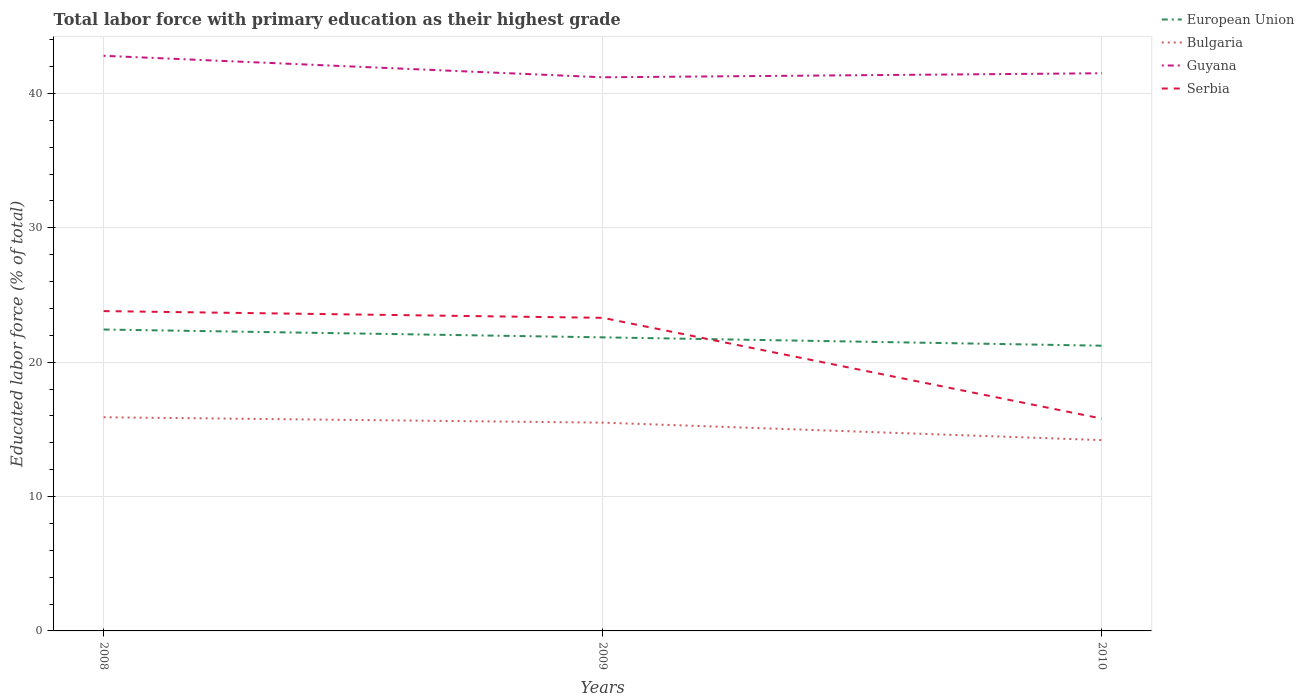Does the line corresponding to Guyana intersect with the line corresponding to European Union?
Your response must be concise. No. Is the number of lines equal to the number of legend labels?
Make the answer very short. Yes. Across all years, what is the maximum percentage of total labor force with primary education in European Union?
Ensure brevity in your answer.  21.22. What is the total percentage of total labor force with primary education in Serbia in the graph?
Ensure brevity in your answer.  7.5. What is the difference between the highest and the second highest percentage of total labor force with primary education in European Union?
Give a very brief answer. 1.2. What is the difference between the highest and the lowest percentage of total labor force with primary education in Serbia?
Your answer should be compact. 2. Is the percentage of total labor force with primary education in Bulgaria strictly greater than the percentage of total labor force with primary education in Serbia over the years?
Give a very brief answer. Yes. How many years are there in the graph?
Provide a succinct answer. 3. What is the difference between two consecutive major ticks on the Y-axis?
Your answer should be compact. 10. Does the graph contain any zero values?
Provide a short and direct response. No. Where does the legend appear in the graph?
Offer a terse response. Top right. How many legend labels are there?
Make the answer very short. 4. How are the legend labels stacked?
Ensure brevity in your answer.  Vertical. What is the title of the graph?
Make the answer very short. Total labor force with primary education as their highest grade. Does "Ukraine" appear as one of the legend labels in the graph?
Your response must be concise. No. What is the label or title of the Y-axis?
Your answer should be compact. Educated labor force (% of total). What is the Educated labor force (% of total) of European Union in 2008?
Offer a very short reply. 22.43. What is the Educated labor force (% of total) of Bulgaria in 2008?
Make the answer very short. 15.9. What is the Educated labor force (% of total) in Guyana in 2008?
Give a very brief answer. 42.8. What is the Educated labor force (% of total) in Serbia in 2008?
Provide a succinct answer. 23.8. What is the Educated labor force (% of total) in European Union in 2009?
Provide a short and direct response. 21.85. What is the Educated labor force (% of total) of Guyana in 2009?
Ensure brevity in your answer.  41.2. What is the Educated labor force (% of total) of Serbia in 2009?
Offer a terse response. 23.3. What is the Educated labor force (% of total) in European Union in 2010?
Your response must be concise. 21.22. What is the Educated labor force (% of total) in Bulgaria in 2010?
Make the answer very short. 14.2. What is the Educated labor force (% of total) of Guyana in 2010?
Your answer should be compact. 41.5. What is the Educated labor force (% of total) in Serbia in 2010?
Provide a succinct answer. 15.8. Across all years, what is the maximum Educated labor force (% of total) of European Union?
Your response must be concise. 22.43. Across all years, what is the maximum Educated labor force (% of total) of Bulgaria?
Provide a short and direct response. 15.9. Across all years, what is the maximum Educated labor force (% of total) in Guyana?
Your response must be concise. 42.8. Across all years, what is the maximum Educated labor force (% of total) of Serbia?
Make the answer very short. 23.8. Across all years, what is the minimum Educated labor force (% of total) in European Union?
Offer a very short reply. 21.22. Across all years, what is the minimum Educated labor force (% of total) in Bulgaria?
Keep it short and to the point. 14.2. Across all years, what is the minimum Educated labor force (% of total) in Guyana?
Provide a short and direct response. 41.2. Across all years, what is the minimum Educated labor force (% of total) in Serbia?
Offer a very short reply. 15.8. What is the total Educated labor force (% of total) in European Union in the graph?
Your response must be concise. 65.5. What is the total Educated labor force (% of total) in Bulgaria in the graph?
Give a very brief answer. 45.6. What is the total Educated labor force (% of total) in Guyana in the graph?
Your answer should be very brief. 125.5. What is the total Educated labor force (% of total) in Serbia in the graph?
Your answer should be very brief. 62.9. What is the difference between the Educated labor force (% of total) in European Union in 2008 and that in 2009?
Provide a succinct answer. 0.58. What is the difference between the Educated labor force (% of total) in Guyana in 2008 and that in 2009?
Give a very brief answer. 1.6. What is the difference between the Educated labor force (% of total) of European Union in 2008 and that in 2010?
Make the answer very short. 1.2. What is the difference between the Educated labor force (% of total) in Bulgaria in 2008 and that in 2010?
Your answer should be very brief. 1.7. What is the difference between the Educated labor force (% of total) of Guyana in 2008 and that in 2010?
Provide a succinct answer. 1.3. What is the difference between the Educated labor force (% of total) in Serbia in 2008 and that in 2010?
Make the answer very short. 8. What is the difference between the Educated labor force (% of total) in European Union in 2009 and that in 2010?
Offer a terse response. 0.62. What is the difference between the Educated labor force (% of total) of Bulgaria in 2009 and that in 2010?
Your answer should be compact. 1.3. What is the difference between the Educated labor force (% of total) of Guyana in 2009 and that in 2010?
Offer a very short reply. -0.3. What is the difference between the Educated labor force (% of total) of Serbia in 2009 and that in 2010?
Offer a terse response. 7.5. What is the difference between the Educated labor force (% of total) in European Union in 2008 and the Educated labor force (% of total) in Bulgaria in 2009?
Keep it short and to the point. 6.93. What is the difference between the Educated labor force (% of total) in European Union in 2008 and the Educated labor force (% of total) in Guyana in 2009?
Your answer should be very brief. -18.77. What is the difference between the Educated labor force (% of total) in European Union in 2008 and the Educated labor force (% of total) in Serbia in 2009?
Your answer should be compact. -0.87. What is the difference between the Educated labor force (% of total) of Bulgaria in 2008 and the Educated labor force (% of total) of Guyana in 2009?
Your answer should be very brief. -25.3. What is the difference between the Educated labor force (% of total) in European Union in 2008 and the Educated labor force (% of total) in Bulgaria in 2010?
Ensure brevity in your answer.  8.23. What is the difference between the Educated labor force (% of total) of European Union in 2008 and the Educated labor force (% of total) of Guyana in 2010?
Ensure brevity in your answer.  -19.07. What is the difference between the Educated labor force (% of total) of European Union in 2008 and the Educated labor force (% of total) of Serbia in 2010?
Your answer should be compact. 6.63. What is the difference between the Educated labor force (% of total) in Bulgaria in 2008 and the Educated labor force (% of total) in Guyana in 2010?
Ensure brevity in your answer.  -25.6. What is the difference between the Educated labor force (% of total) in European Union in 2009 and the Educated labor force (% of total) in Bulgaria in 2010?
Your response must be concise. 7.65. What is the difference between the Educated labor force (% of total) of European Union in 2009 and the Educated labor force (% of total) of Guyana in 2010?
Give a very brief answer. -19.65. What is the difference between the Educated labor force (% of total) in European Union in 2009 and the Educated labor force (% of total) in Serbia in 2010?
Give a very brief answer. 6.05. What is the difference between the Educated labor force (% of total) of Bulgaria in 2009 and the Educated labor force (% of total) of Guyana in 2010?
Your answer should be very brief. -26. What is the difference between the Educated labor force (% of total) in Bulgaria in 2009 and the Educated labor force (% of total) in Serbia in 2010?
Offer a terse response. -0.3. What is the difference between the Educated labor force (% of total) of Guyana in 2009 and the Educated labor force (% of total) of Serbia in 2010?
Make the answer very short. 25.4. What is the average Educated labor force (% of total) of European Union per year?
Provide a short and direct response. 21.83. What is the average Educated labor force (% of total) in Bulgaria per year?
Your answer should be compact. 15.2. What is the average Educated labor force (% of total) in Guyana per year?
Your response must be concise. 41.83. What is the average Educated labor force (% of total) in Serbia per year?
Provide a succinct answer. 20.97. In the year 2008, what is the difference between the Educated labor force (% of total) in European Union and Educated labor force (% of total) in Bulgaria?
Offer a terse response. 6.53. In the year 2008, what is the difference between the Educated labor force (% of total) in European Union and Educated labor force (% of total) in Guyana?
Your answer should be compact. -20.37. In the year 2008, what is the difference between the Educated labor force (% of total) of European Union and Educated labor force (% of total) of Serbia?
Keep it short and to the point. -1.37. In the year 2008, what is the difference between the Educated labor force (% of total) of Bulgaria and Educated labor force (% of total) of Guyana?
Your answer should be very brief. -26.9. In the year 2008, what is the difference between the Educated labor force (% of total) in Guyana and Educated labor force (% of total) in Serbia?
Your answer should be very brief. 19. In the year 2009, what is the difference between the Educated labor force (% of total) of European Union and Educated labor force (% of total) of Bulgaria?
Ensure brevity in your answer.  6.35. In the year 2009, what is the difference between the Educated labor force (% of total) in European Union and Educated labor force (% of total) in Guyana?
Offer a terse response. -19.35. In the year 2009, what is the difference between the Educated labor force (% of total) of European Union and Educated labor force (% of total) of Serbia?
Offer a terse response. -1.45. In the year 2009, what is the difference between the Educated labor force (% of total) in Bulgaria and Educated labor force (% of total) in Guyana?
Your answer should be very brief. -25.7. In the year 2009, what is the difference between the Educated labor force (% of total) in Bulgaria and Educated labor force (% of total) in Serbia?
Your response must be concise. -7.8. In the year 2009, what is the difference between the Educated labor force (% of total) of Guyana and Educated labor force (% of total) of Serbia?
Provide a succinct answer. 17.9. In the year 2010, what is the difference between the Educated labor force (% of total) of European Union and Educated labor force (% of total) of Bulgaria?
Your answer should be very brief. 7.03. In the year 2010, what is the difference between the Educated labor force (% of total) in European Union and Educated labor force (% of total) in Guyana?
Offer a terse response. -20.27. In the year 2010, what is the difference between the Educated labor force (% of total) of European Union and Educated labor force (% of total) of Serbia?
Your response must be concise. 5.42. In the year 2010, what is the difference between the Educated labor force (% of total) in Bulgaria and Educated labor force (% of total) in Guyana?
Ensure brevity in your answer.  -27.3. In the year 2010, what is the difference between the Educated labor force (% of total) of Guyana and Educated labor force (% of total) of Serbia?
Offer a very short reply. 25.7. What is the ratio of the Educated labor force (% of total) in European Union in 2008 to that in 2009?
Your answer should be very brief. 1.03. What is the ratio of the Educated labor force (% of total) of Bulgaria in 2008 to that in 2009?
Your answer should be very brief. 1.03. What is the ratio of the Educated labor force (% of total) of Guyana in 2008 to that in 2009?
Provide a succinct answer. 1.04. What is the ratio of the Educated labor force (% of total) of Serbia in 2008 to that in 2009?
Provide a short and direct response. 1.02. What is the ratio of the Educated labor force (% of total) of European Union in 2008 to that in 2010?
Your answer should be very brief. 1.06. What is the ratio of the Educated labor force (% of total) of Bulgaria in 2008 to that in 2010?
Your answer should be very brief. 1.12. What is the ratio of the Educated labor force (% of total) in Guyana in 2008 to that in 2010?
Ensure brevity in your answer.  1.03. What is the ratio of the Educated labor force (% of total) of Serbia in 2008 to that in 2010?
Offer a terse response. 1.51. What is the ratio of the Educated labor force (% of total) of European Union in 2009 to that in 2010?
Your answer should be very brief. 1.03. What is the ratio of the Educated labor force (% of total) of Bulgaria in 2009 to that in 2010?
Provide a short and direct response. 1.09. What is the ratio of the Educated labor force (% of total) in Serbia in 2009 to that in 2010?
Make the answer very short. 1.47. What is the difference between the highest and the second highest Educated labor force (% of total) in European Union?
Offer a terse response. 0.58. What is the difference between the highest and the second highest Educated labor force (% of total) of Guyana?
Your response must be concise. 1.3. What is the difference between the highest and the lowest Educated labor force (% of total) in European Union?
Your answer should be compact. 1.2. What is the difference between the highest and the lowest Educated labor force (% of total) in Bulgaria?
Offer a very short reply. 1.7. What is the difference between the highest and the lowest Educated labor force (% of total) in Guyana?
Your response must be concise. 1.6. What is the difference between the highest and the lowest Educated labor force (% of total) in Serbia?
Provide a short and direct response. 8. 